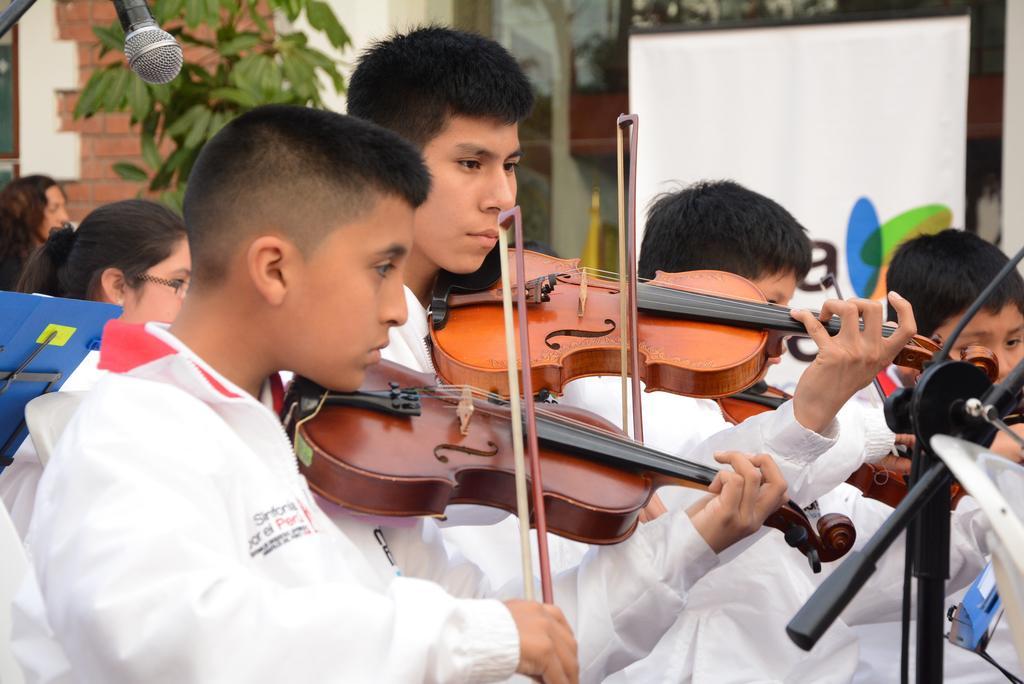Describe this image in one or two sentences. In this picture I can see group of people standing and holding violins with bows, and there is a mike with a mike stand, and in the background there are group of people, a tree, a screen and a house. 